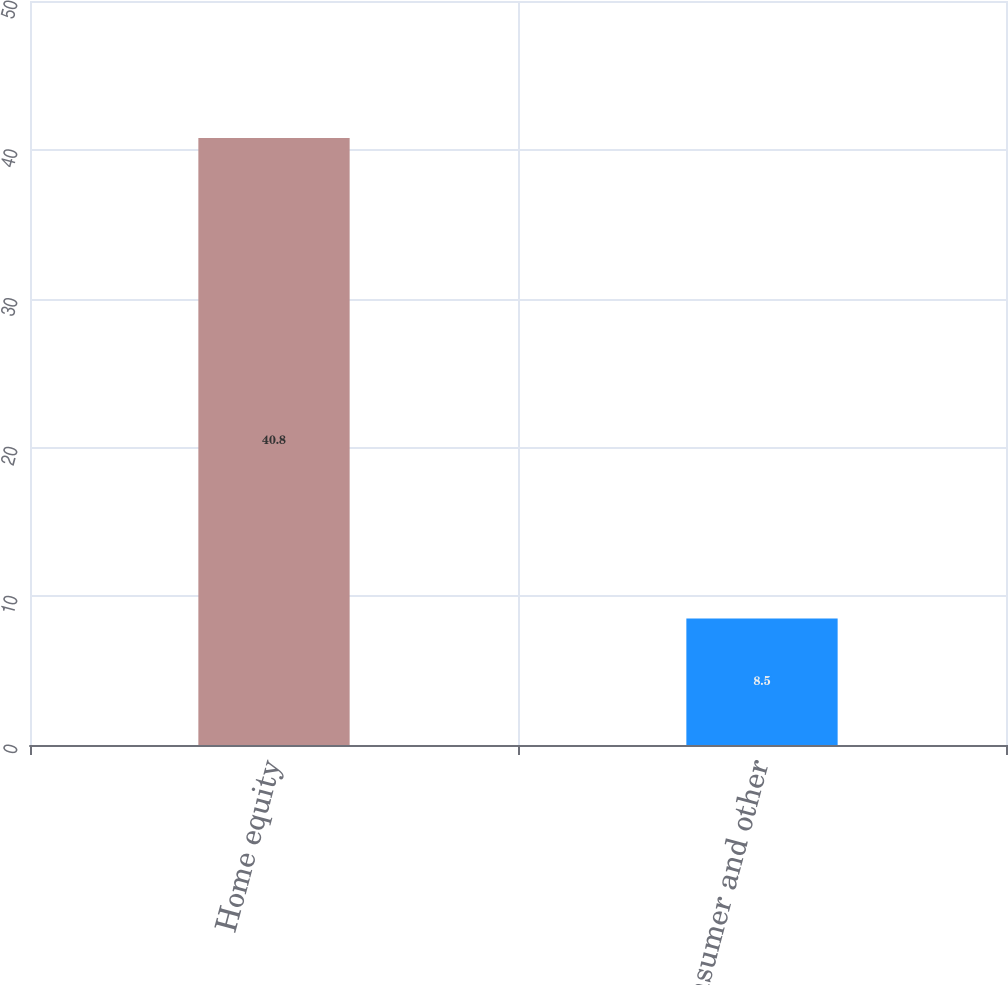<chart> <loc_0><loc_0><loc_500><loc_500><bar_chart><fcel>Home equity<fcel>Consumer and other<nl><fcel>40.8<fcel>8.5<nl></chart> 